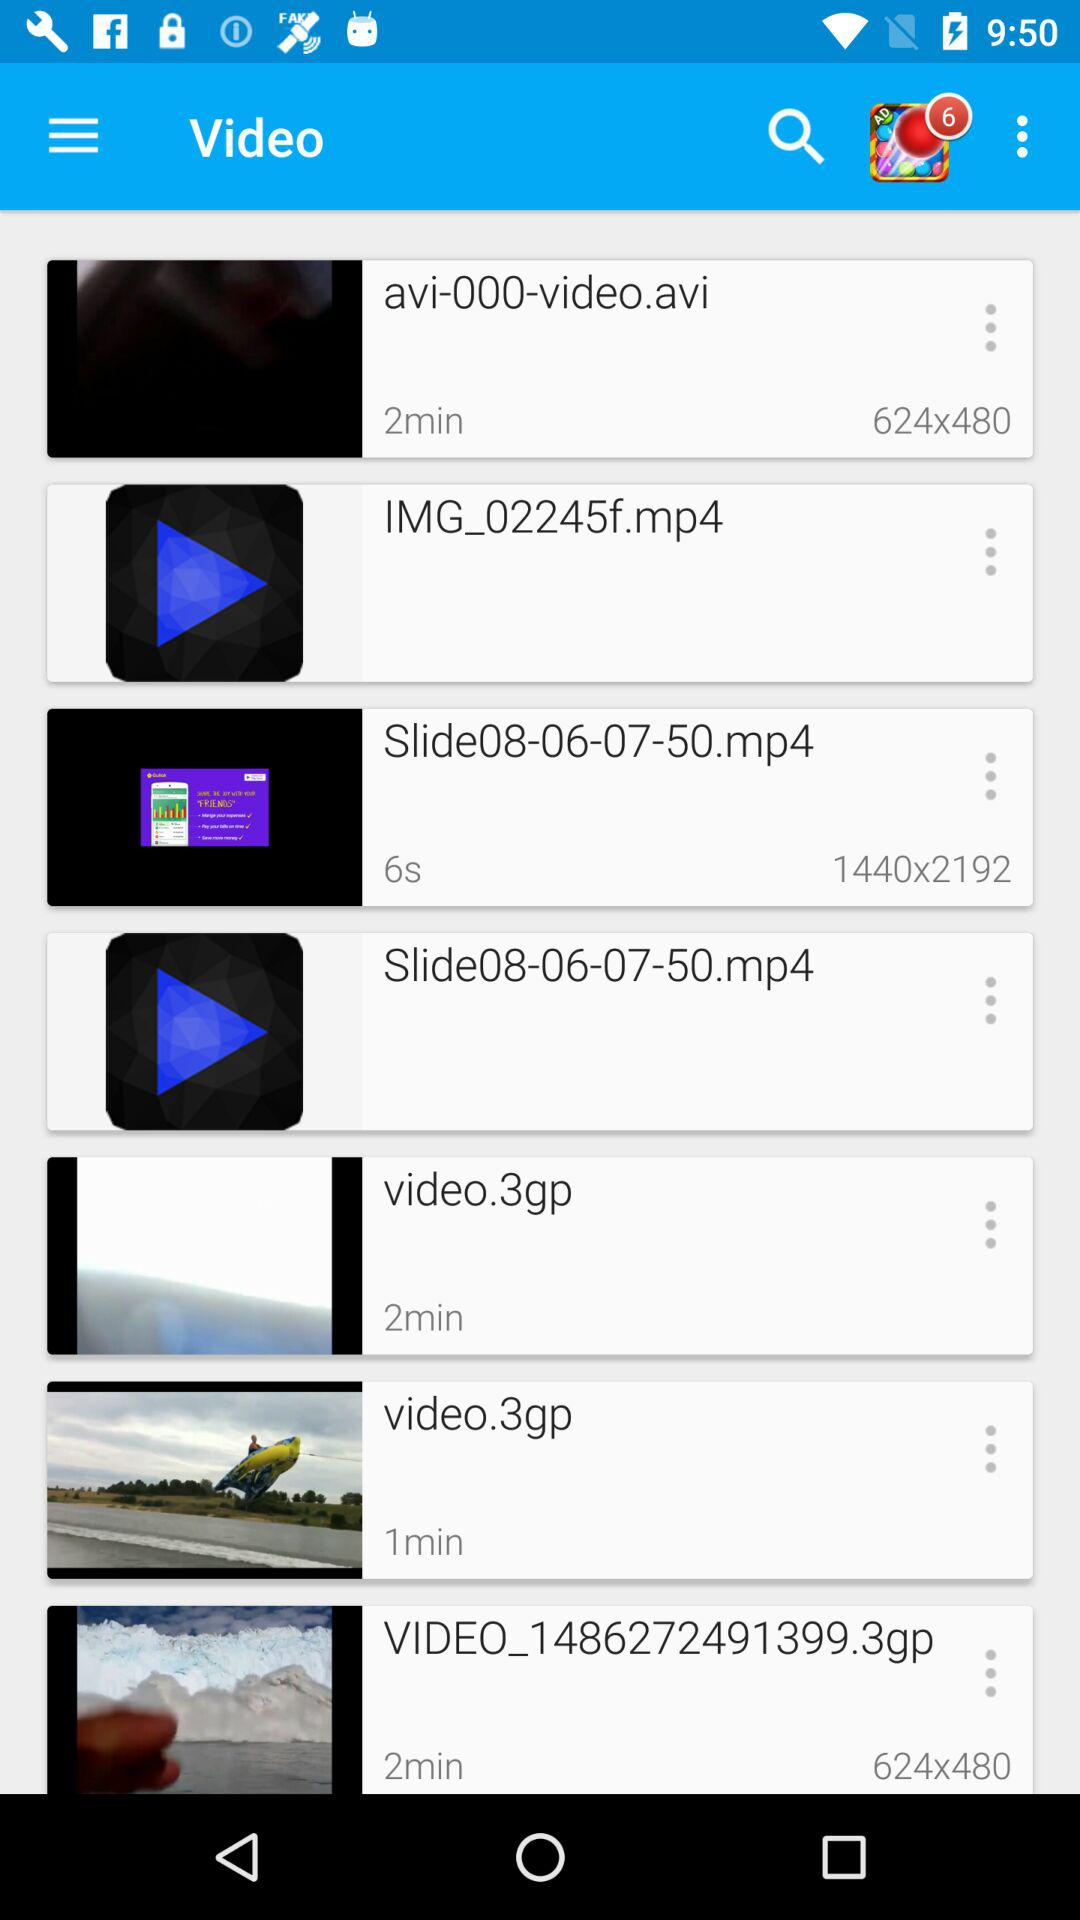How many videos are longer than 1 minute?
Answer the question using a single word or phrase. 4 